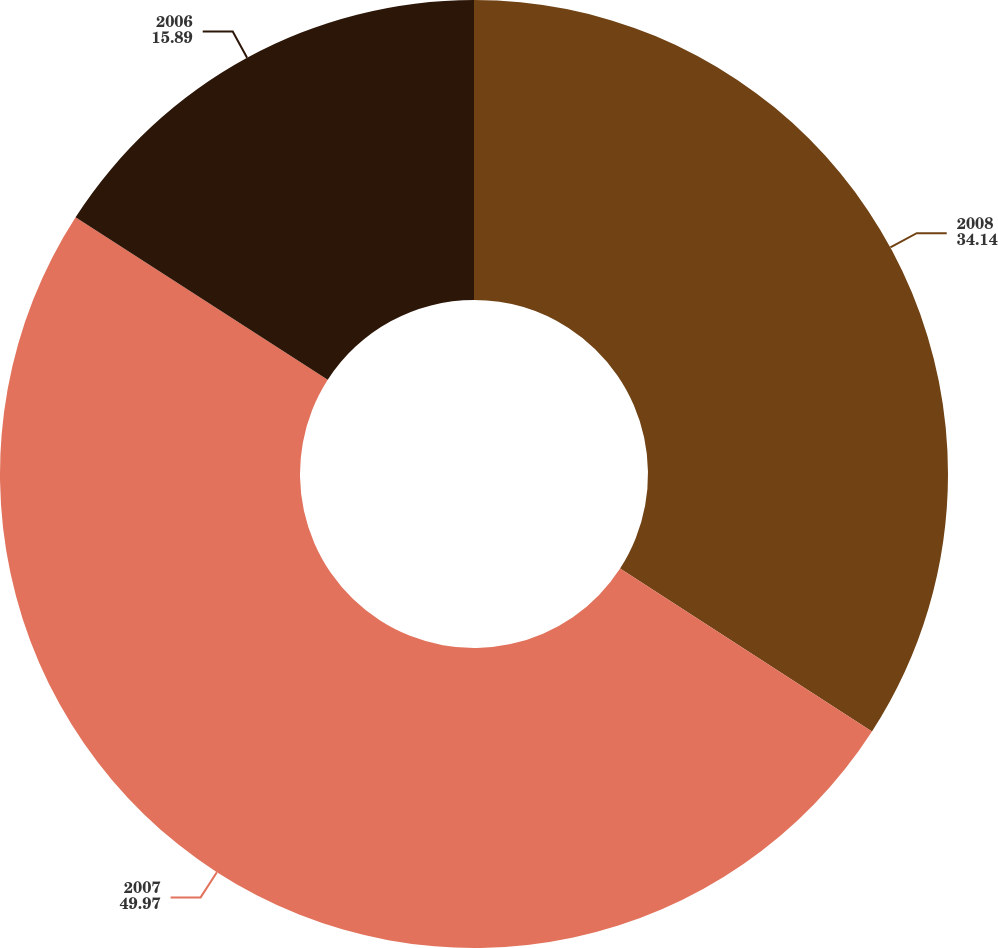Convert chart to OTSL. <chart><loc_0><loc_0><loc_500><loc_500><pie_chart><fcel>2008<fcel>2007<fcel>2006<nl><fcel>34.14%<fcel>49.97%<fcel>15.89%<nl></chart> 